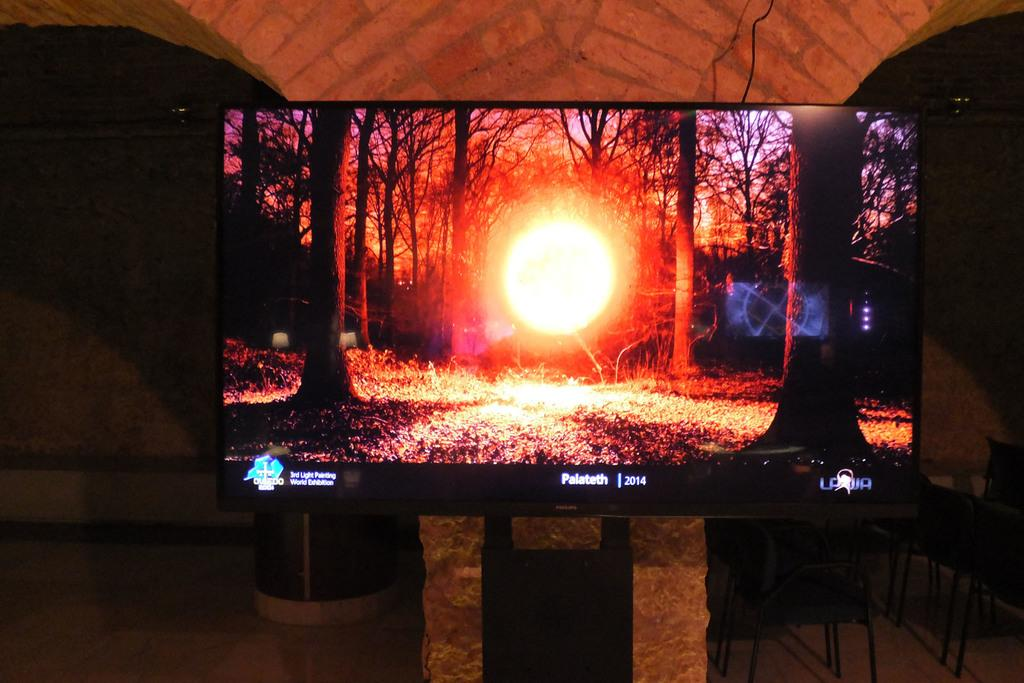<image>
Describe the image concisely. a Palateth television that has a red sun on it 